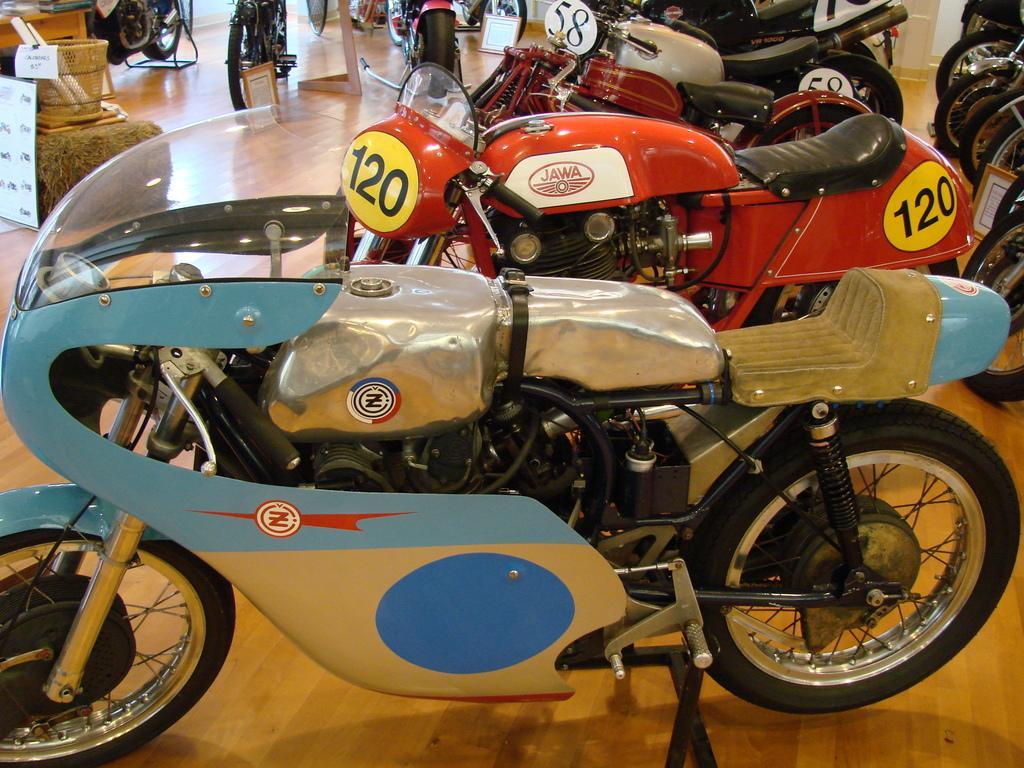Describe this image in one or two sentences. In this image we can see different models of motorcycles which are displayed, at the corner of the image we can see two paper rolls in a basket, there is a placard, and a table. 